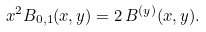Convert formula to latex. <formula><loc_0><loc_0><loc_500><loc_500>x ^ { 2 } B _ { 0 , 1 } ( x , y ) = 2 \, B ^ { ( y ) } ( x , y ) .</formula> 